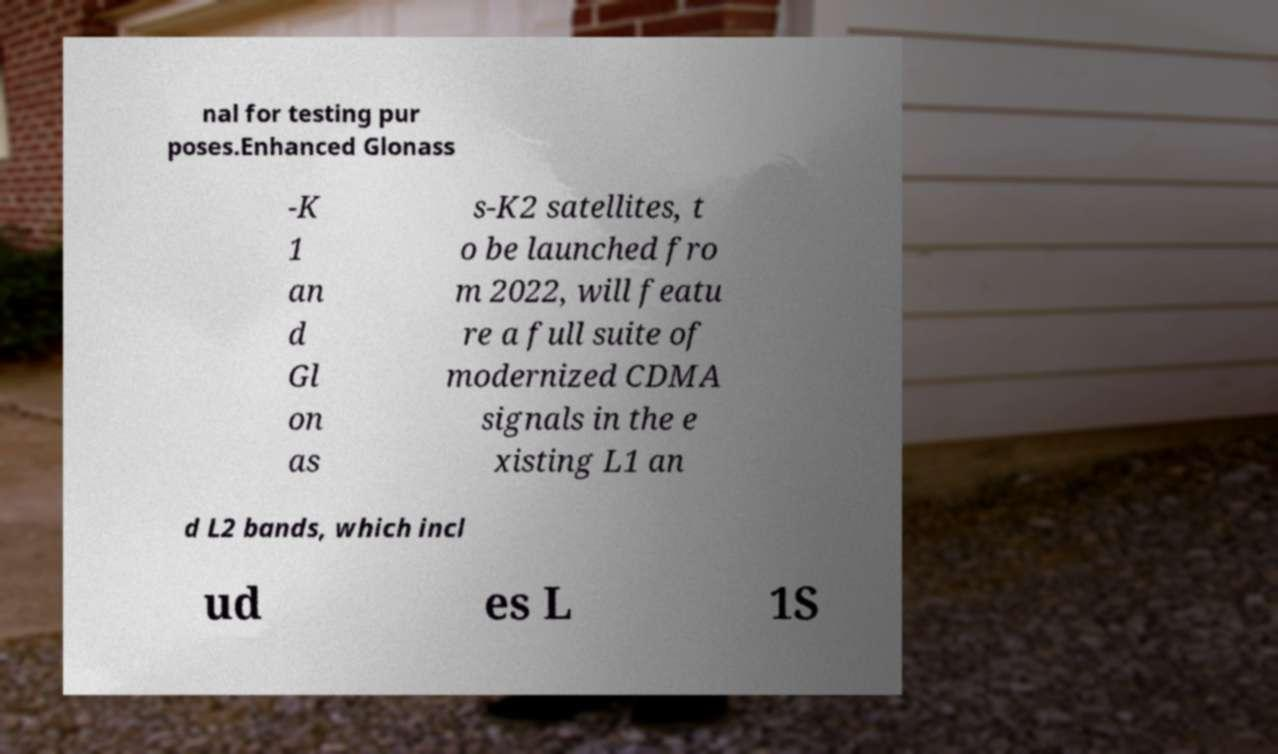Could you assist in decoding the text presented in this image and type it out clearly? nal for testing pur poses.Enhanced Glonass -K 1 an d Gl on as s-K2 satellites, t o be launched fro m 2022, will featu re a full suite of modernized CDMA signals in the e xisting L1 an d L2 bands, which incl ud es L 1S 